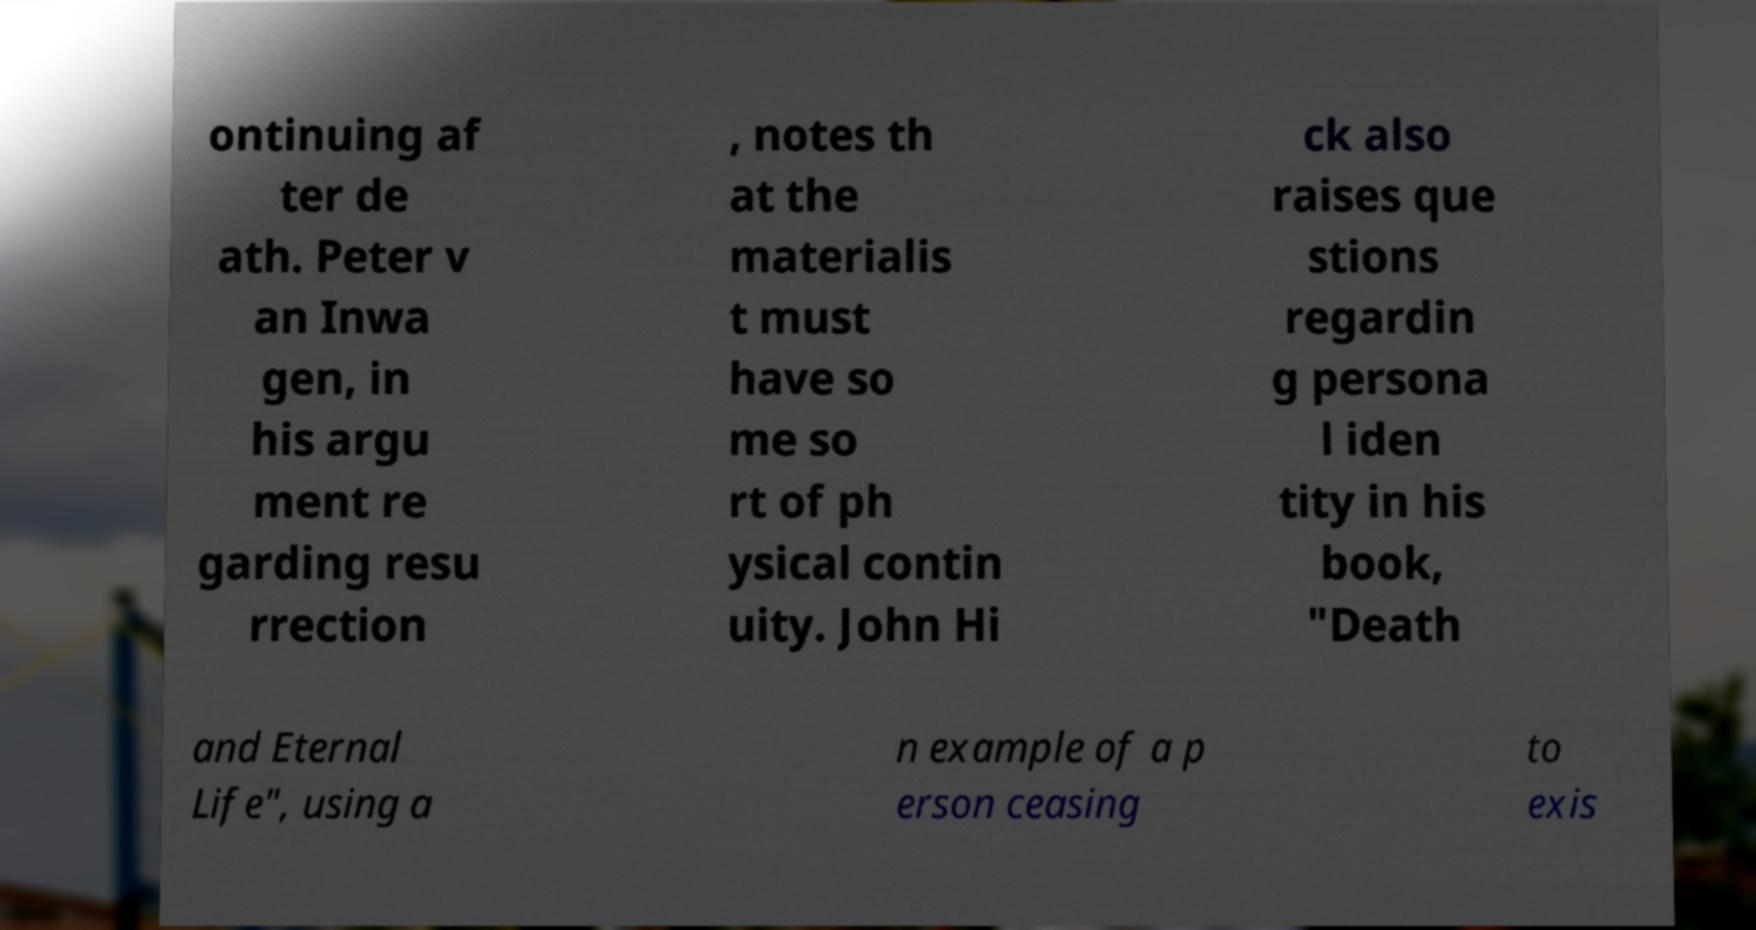Please identify and transcribe the text found in this image. ontinuing af ter de ath. Peter v an Inwa gen, in his argu ment re garding resu rrection , notes th at the materialis t must have so me so rt of ph ysical contin uity. John Hi ck also raises que stions regardin g persona l iden tity in his book, "Death and Eternal Life", using a n example of a p erson ceasing to exis 